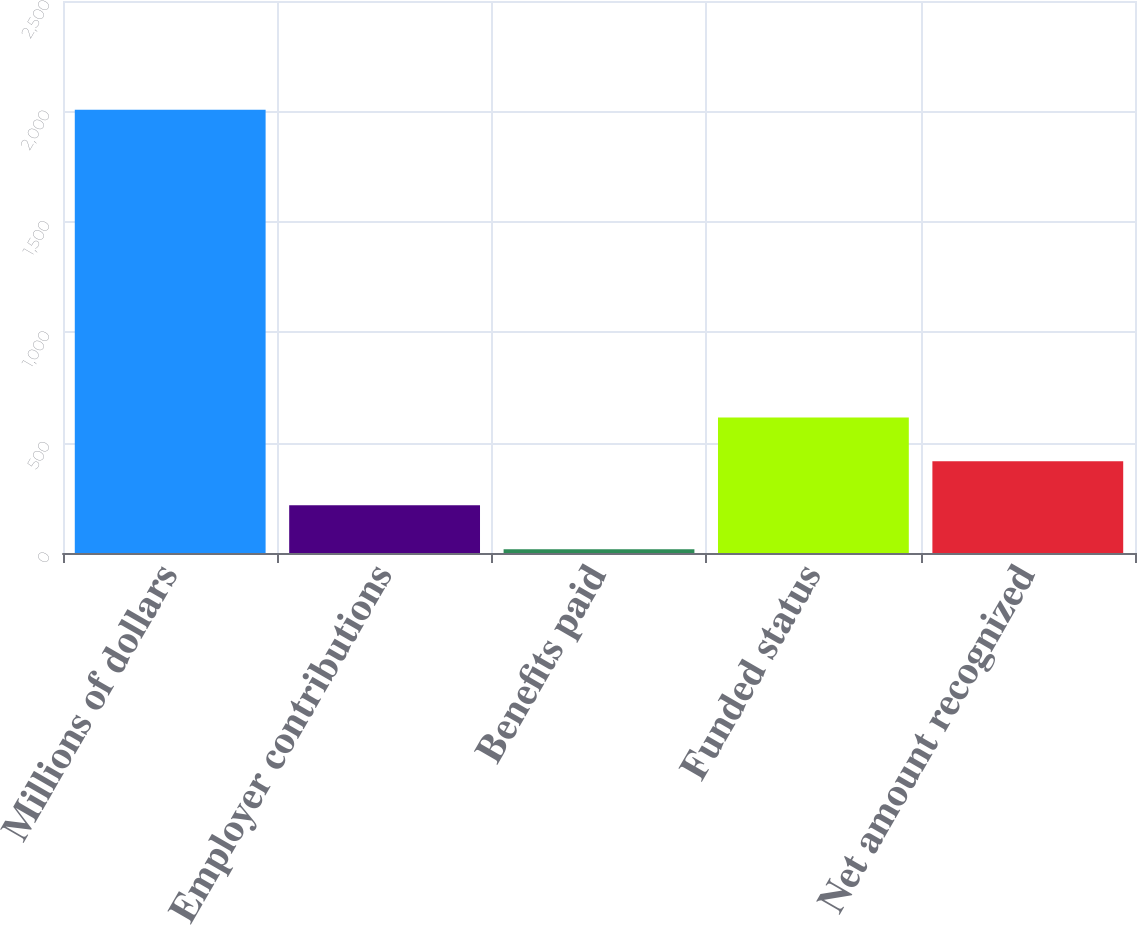<chart> <loc_0><loc_0><loc_500><loc_500><bar_chart><fcel>Millions of dollars<fcel>Employer contributions<fcel>Benefits paid<fcel>Funded status<fcel>Net amount recognized<nl><fcel>2007<fcel>216<fcel>17<fcel>614<fcel>415<nl></chart> 